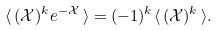Convert formula to latex. <formula><loc_0><loc_0><loc_500><loc_500>\langle \, ( \mathcal { X } ) ^ { k } e ^ { - \mathcal { X } } \, \rangle = ( - 1 ) ^ { k } \langle \, ( \mathcal { X } ) ^ { k } \, \rangle .</formula> 